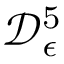<formula> <loc_0><loc_0><loc_500><loc_500>\mathcal { D } _ { \epsilon } ^ { 5 }</formula> 